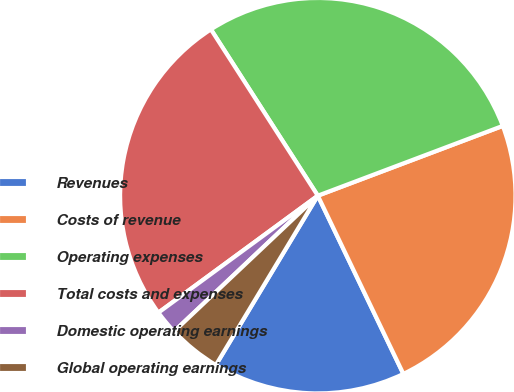<chart> <loc_0><loc_0><loc_500><loc_500><pie_chart><fcel>Revenues<fcel>Costs of revenue<fcel>Operating expenses<fcel>Total costs and expenses<fcel>Domestic operating earnings<fcel>Global operating earnings<nl><fcel>15.75%<fcel>23.62%<fcel>28.35%<fcel>25.98%<fcel>1.97%<fcel>4.33%<nl></chart> 